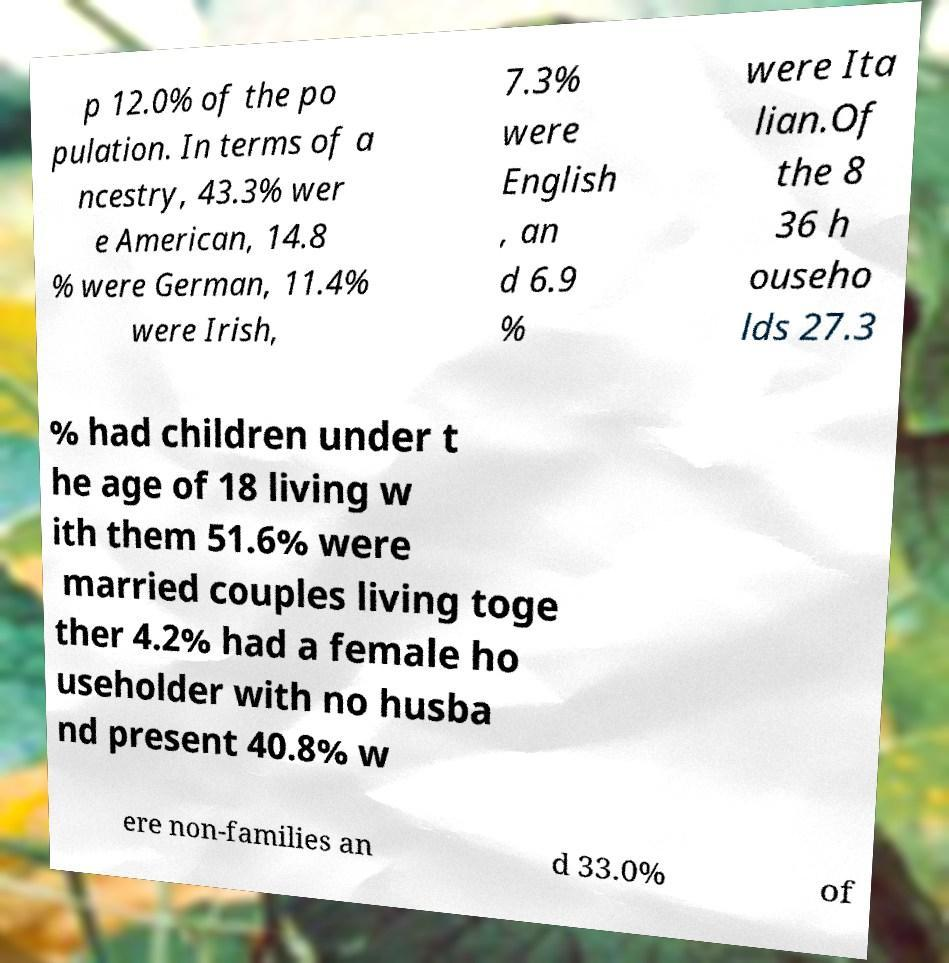I need the written content from this picture converted into text. Can you do that? p 12.0% of the po pulation. In terms of a ncestry, 43.3% wer e American, 14.8 % were German, 11.4% were Irish, 7.3% were English , an d 6.9 % were Ita lian.Of the 8 36 h ouseho lds 27.3 % had children under t he age of 18 living w ith them 51.6% were married couples living toge ther 4.2% had a female ho useholder with no husba nd present 40.8% w ere non-families an d 33.0% of 